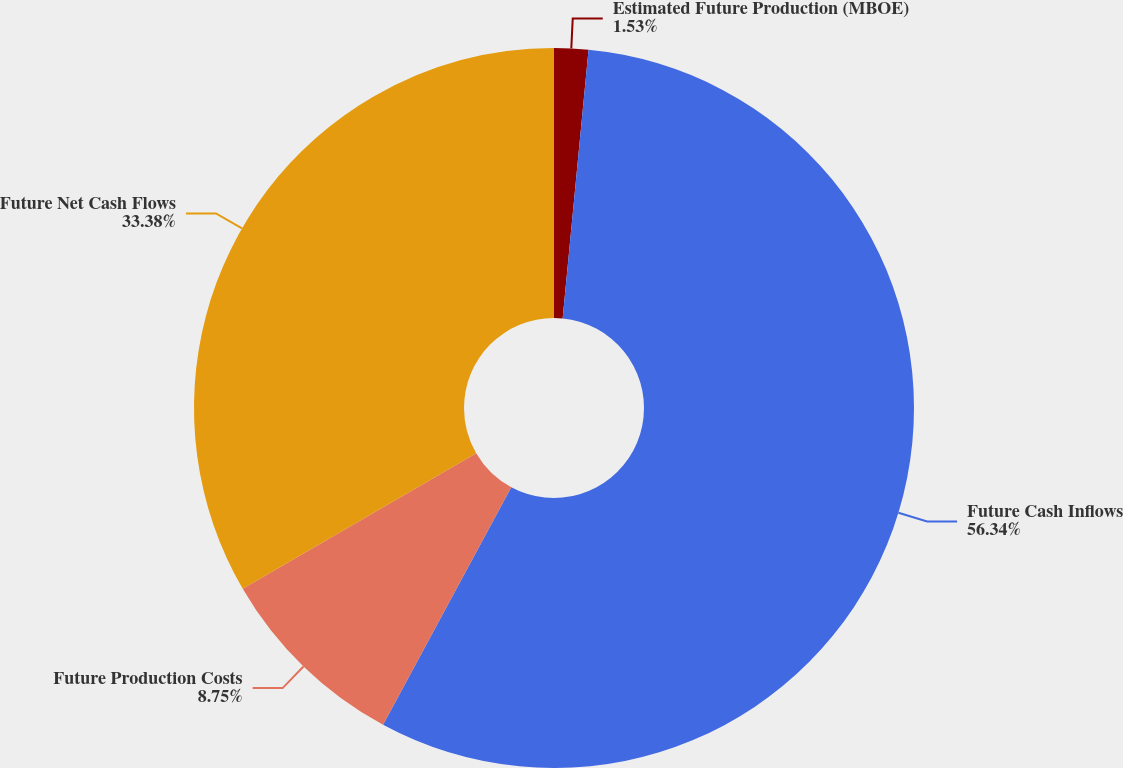<chart> <loc_0><loc_0><loc_500><loc_500><pie_chart><fcel>Estimated Future Production (MBOE)<fcel>Future Cash Inflows<fcel>Future Production Costs<fcel>Future Net Cash Flows<nl><fcel>1.53%<fcel>56.35%<fcel>8.75%<fcel>33.38%<nl></chart> 